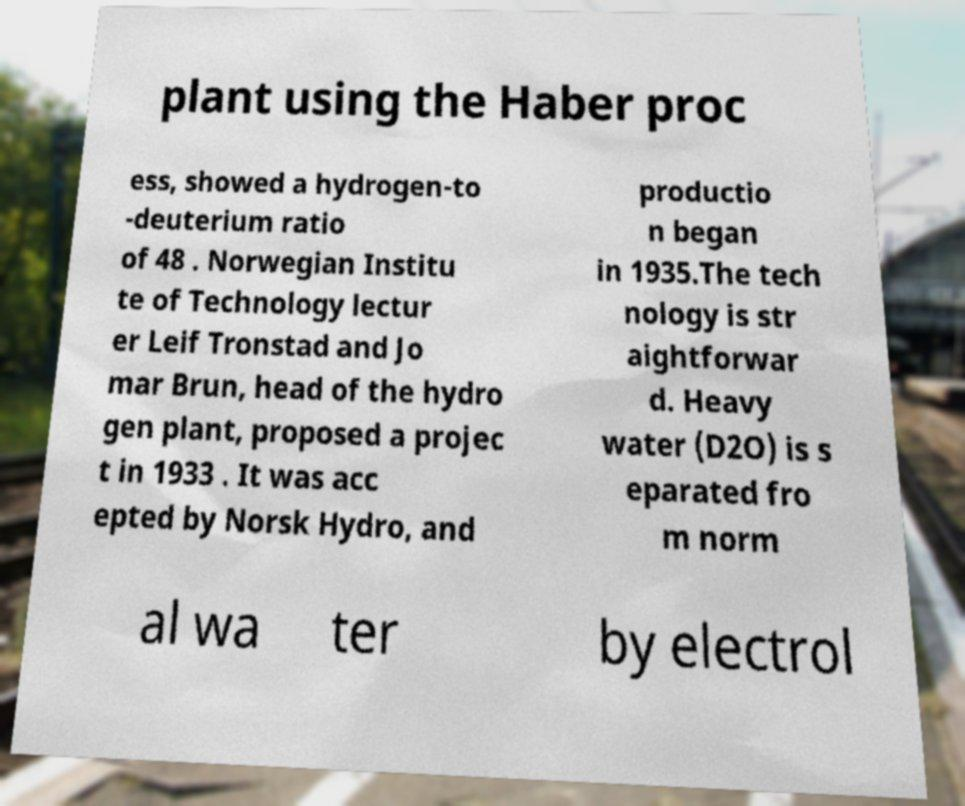There's text embedded in this image that I need extracted. Can you transcribe it verbatim? plant using the Haber proc ess, showed a hydrogen-to -deuterium ratio of 48 . Norwegian Institu te of Technology lectur er Leif Tronstad and Jo mar Brun, head of the hydro gen plant, proposed a projec t in 1933 . It was acc epted by Norsk Hydro, and productio n began in 1935.The tech nology is str aightforwar d. Heavy water (D2O) is s eparated fro m norm al wa ter by electrol 